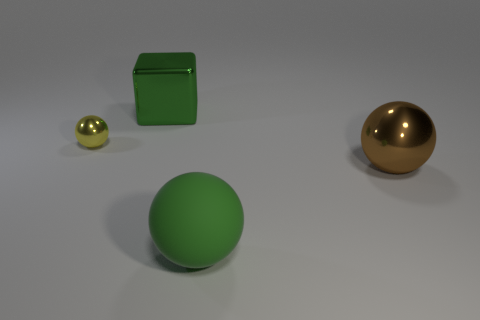Subtract all matte balls. How many balls are left? 2 Subtract 3 spheres. How many spheres are left? 0 Add 4 yellow metal things. How many objects exist? 8 Subtract all yellow spheres. How many spheres are left? 2 Subtract all balls. How many objects are left? 1 Subtract all purple cubes. Subtract all purple cylinders. How many cubes are left? 1 Subtract all blue cylinders. How many brown spheres are left? 1 Subtract all small metal things. Subtract all blue balls. How many objects are left? 3 Add 4 green matte balls. How many green matte balls are left? 5 Add 1 tiny gray objects. How many tiny gray objects exist? 1 